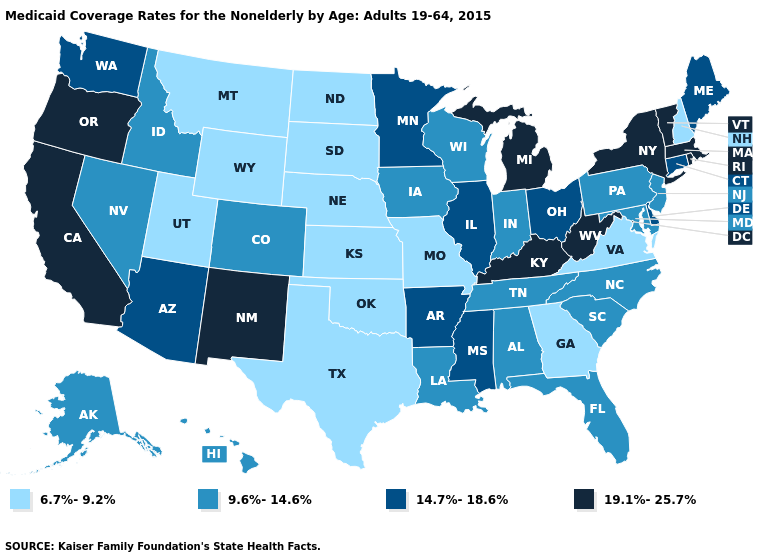Does Oregon have the highest value in the USA?
Keep it brief. Yes. What is the highest value in states that border Kansas?
Be succinct. 9.6%-14.6%. Does Rhode Island have the highest value in the USA?
Answer briefly. Yes. Does Louisiana have the lowest value in the South?
Short answer required. No. Name the states that have a value in the range 14.7%-18.6%?
Keep it brief. Arizona, Arkansas, Connecticut, Delaware, Illinois, Maine, Minnesota, Mississippi, Ohio, Washington. What is the value of Tennessee?
Answer briefly. 9.6%-14.6%. What is the value of South Dakota?
Concise answer only. 6.7%-9.2%. Does Oregon have the same value as New Hampshire?
Answer briefly. No. Does the map have missing data?
Quick response, please. No. Among the states that border Illinois , does Kentucky have the highest value?
Be succinct. Yes. Which states have the lowest value in the South?
Give a very brief answer. Georgia, Oklahoma, Texas, Virginia. Name the states that have a value in the range 9.6%-14.6%?
Answer briefly. Alabama, Alaska, Colorado, Florida, Hawaii, Idaho, Indiana, Iowa, Louisiana, Maryland, Nevada, New Jersey, North Carolina, Pennsylvania, South Carolina, Tennessee, Wisconsin. Name the states that have a value in the range 19.1%-25.7%?
Be succinct. California, Kentucky, Massachusetts, Michigan, New Mexico, New York, Oregon, Rhode Island, Vermont, West Virginia. Among the states that border Idaho , does Utah have the lowest value?
Short answer required. Yes. Among the states that border Maryland , does West Virginia have the highest value?
Quick response, please. Yes. 